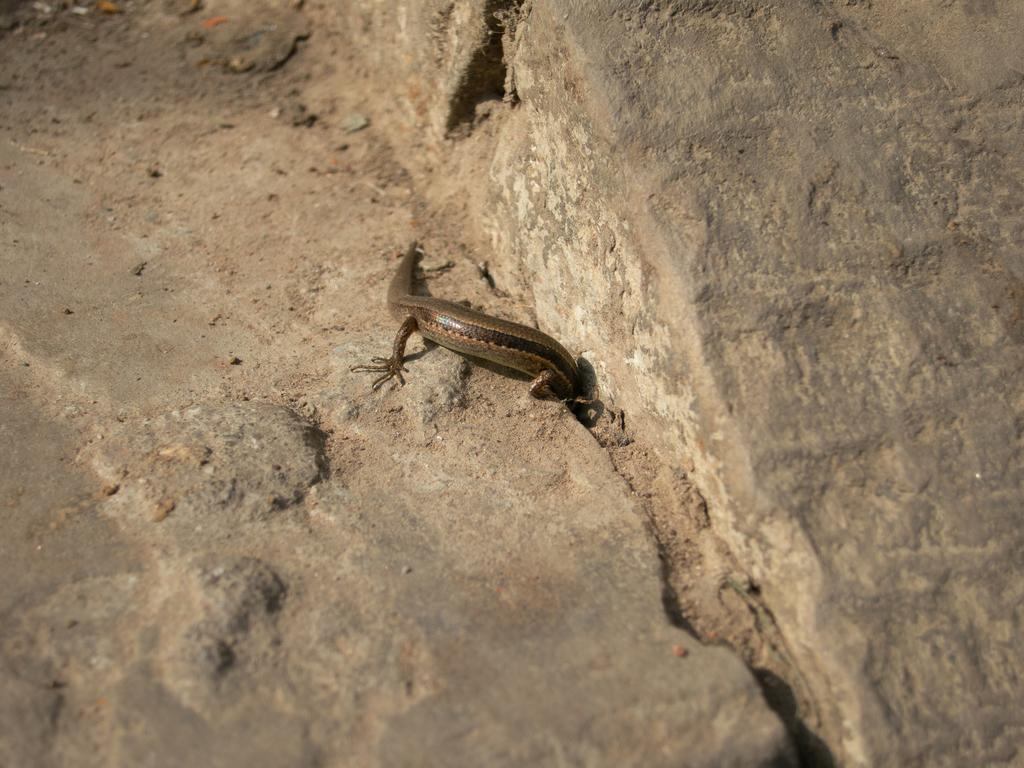What type of animal is present in the image? There is a lizard in the image. What type of natural formation can be seen in the image? There are rocks in the image. What type of pocket can be seen on the lizard in the image? There is no pocket present on the lizard in the image, as lizards do not have pockets. What type of market can be seen in the image? There is no market present in the image; it features a lizard and rocks. 